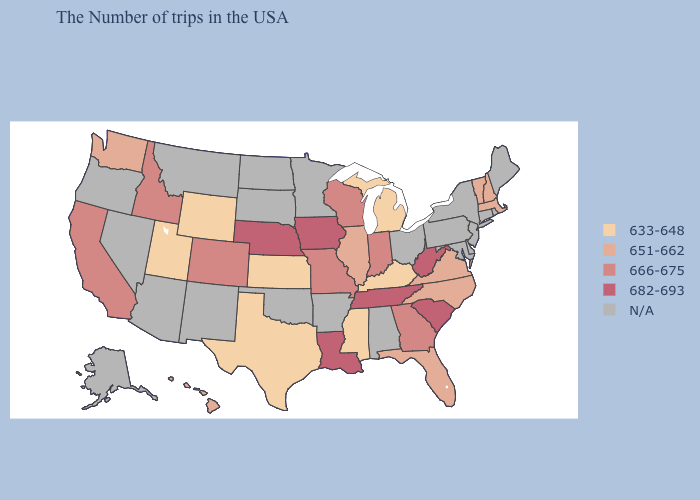What is the value of Nebraska?
Concise answer only. 682-693. Does the map have missing data?
Give a very brief answer. Yes. What is the lowest value in the West?
Keep it brief. 633-648. What is the value of Virginia?
Give a very brief answer. 651-662. What is the value of Montana?
Concise answer only. N/A. What is the lowest value in the USA?
Concise answer only. 633-648. What is the lowest value in the West?
Short answer required. 633-648. What is the value of Iowa?
Concise answer only. 682-693. Which states have the lowest value in the South?
Quick response, please. Kentucky, Mississippi, Texas. What is the value of Kentucky?
Short answer required. 633-648. Which states hav the highest value in the MidWest?
Write a very short answer. Iowa, Nebraska. 